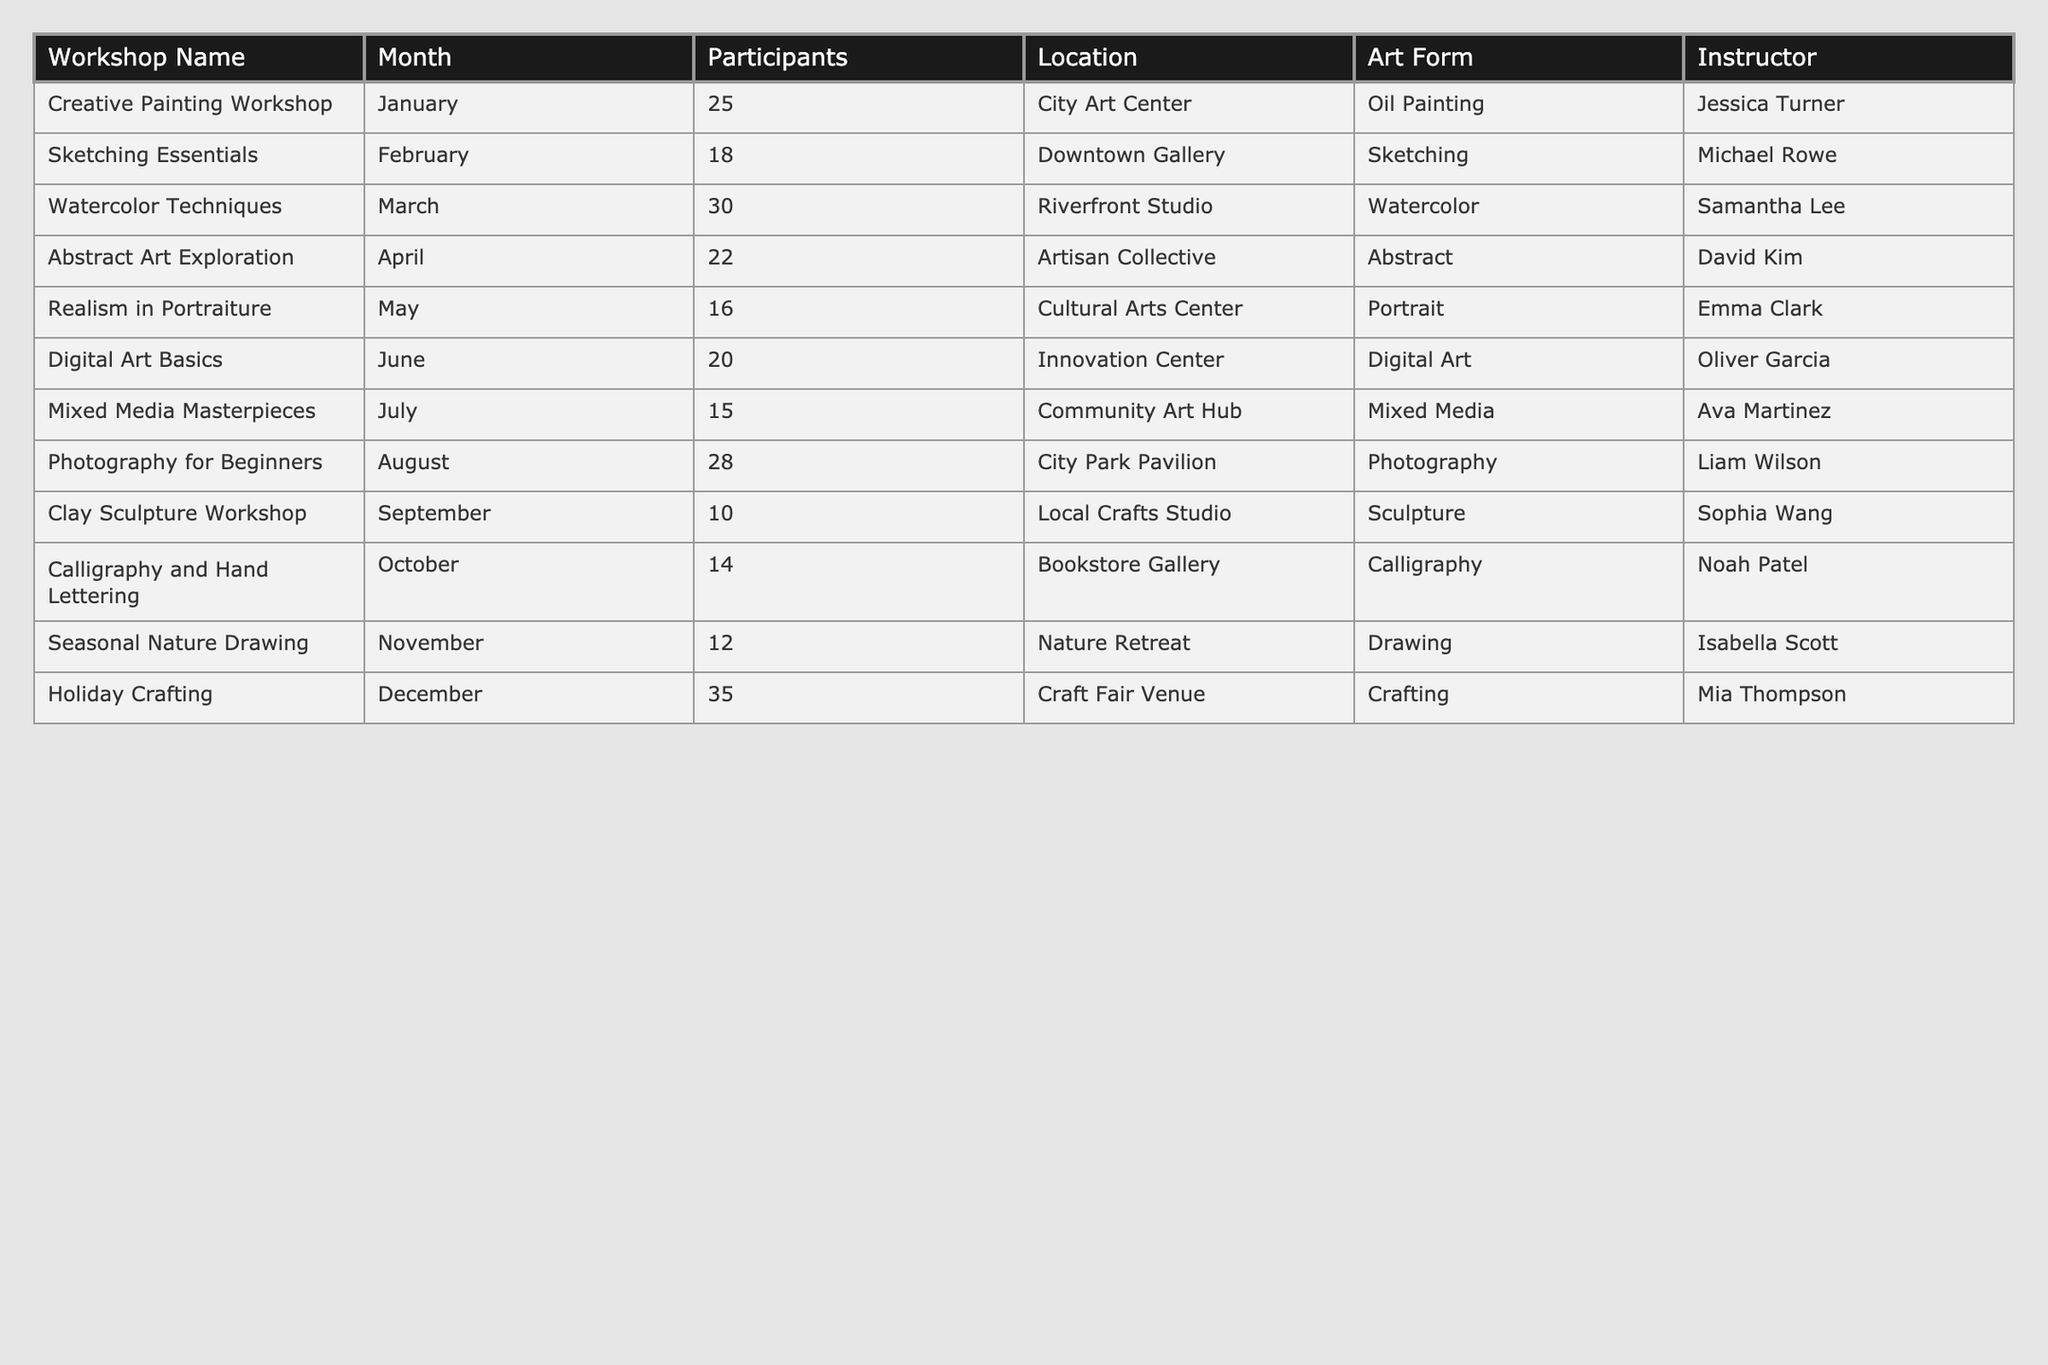What is the total number of participants across all workshops? To find the total number of participants, I need to sum the participants of each workshop: 25 + 18 + 30 + 22 + 16 + 20 + 15 + 28 + 10 + 14 + 12 + 35 =  25 + 18 + 30 + 22 + 16 + 20 + 15 + 28 + 10 + 14 + 12 + 35 =  50 + 30 = 80 + 22 = 102 + 16 = 118 + 20 = 138 + 15 = 153 + 28 = 181 + 10 = 191 + 14 = 205 + 12 = 217 + 35 = 252
Answer: 252 Which art form had the highest number of participants and how many were there? Looking at the "Participants" column, the highest number is 35 in the "Holiday Crafting" workshop.
Answer: Holiday Crafting, 35 Were there any workshops with fewer than 15 participants? Checking the "Participants" column, I can see that the "Clay Sculpture Workshop" had 10 participants and the "Mixed Media Masterpieces" had 15, so yes, there is one workshop with fewer than 15.
Answer: Yes What is the average number of participants per workshop? There are 12 workshops in total. I will sum the participants (252), and then divide by the number of workshops (252 / 12 = 21). Therefore, the average number of participants is 21.
Answer: 21 How many more participants attended the "Holiday Crafting" workshop compared to the "Clay Sculpture Workshop"? "Holiday Crafting" had 35 participants, and "Clay Sculpture Workshop" had 10 participants. The difference is 35 - 10 = 25.
Answer: 25 Which month had the least participation and how many participants were there? Reviewing the table, "Clay Sculpture Workshop" in September had the least participation with only 10 participants.
Answer: September, 10 Was there a month that had exactly the same number of participants as any other month? Comparing the participant numbers across months, I found that the participant count of the "Mixed Media Masterpieces" workshop (15) was the same as the "Realism in Portraiture" workshop.
Answer: Yes What percentage of overall participation did the "Photography for Beginners" workshop represent? The "Photography for Beginners" had 28 participants out of a total of 252. To find the percentage, I calculate (28 / 252) * 100 which is approximately 11.1%.
Answer: 11.1% 